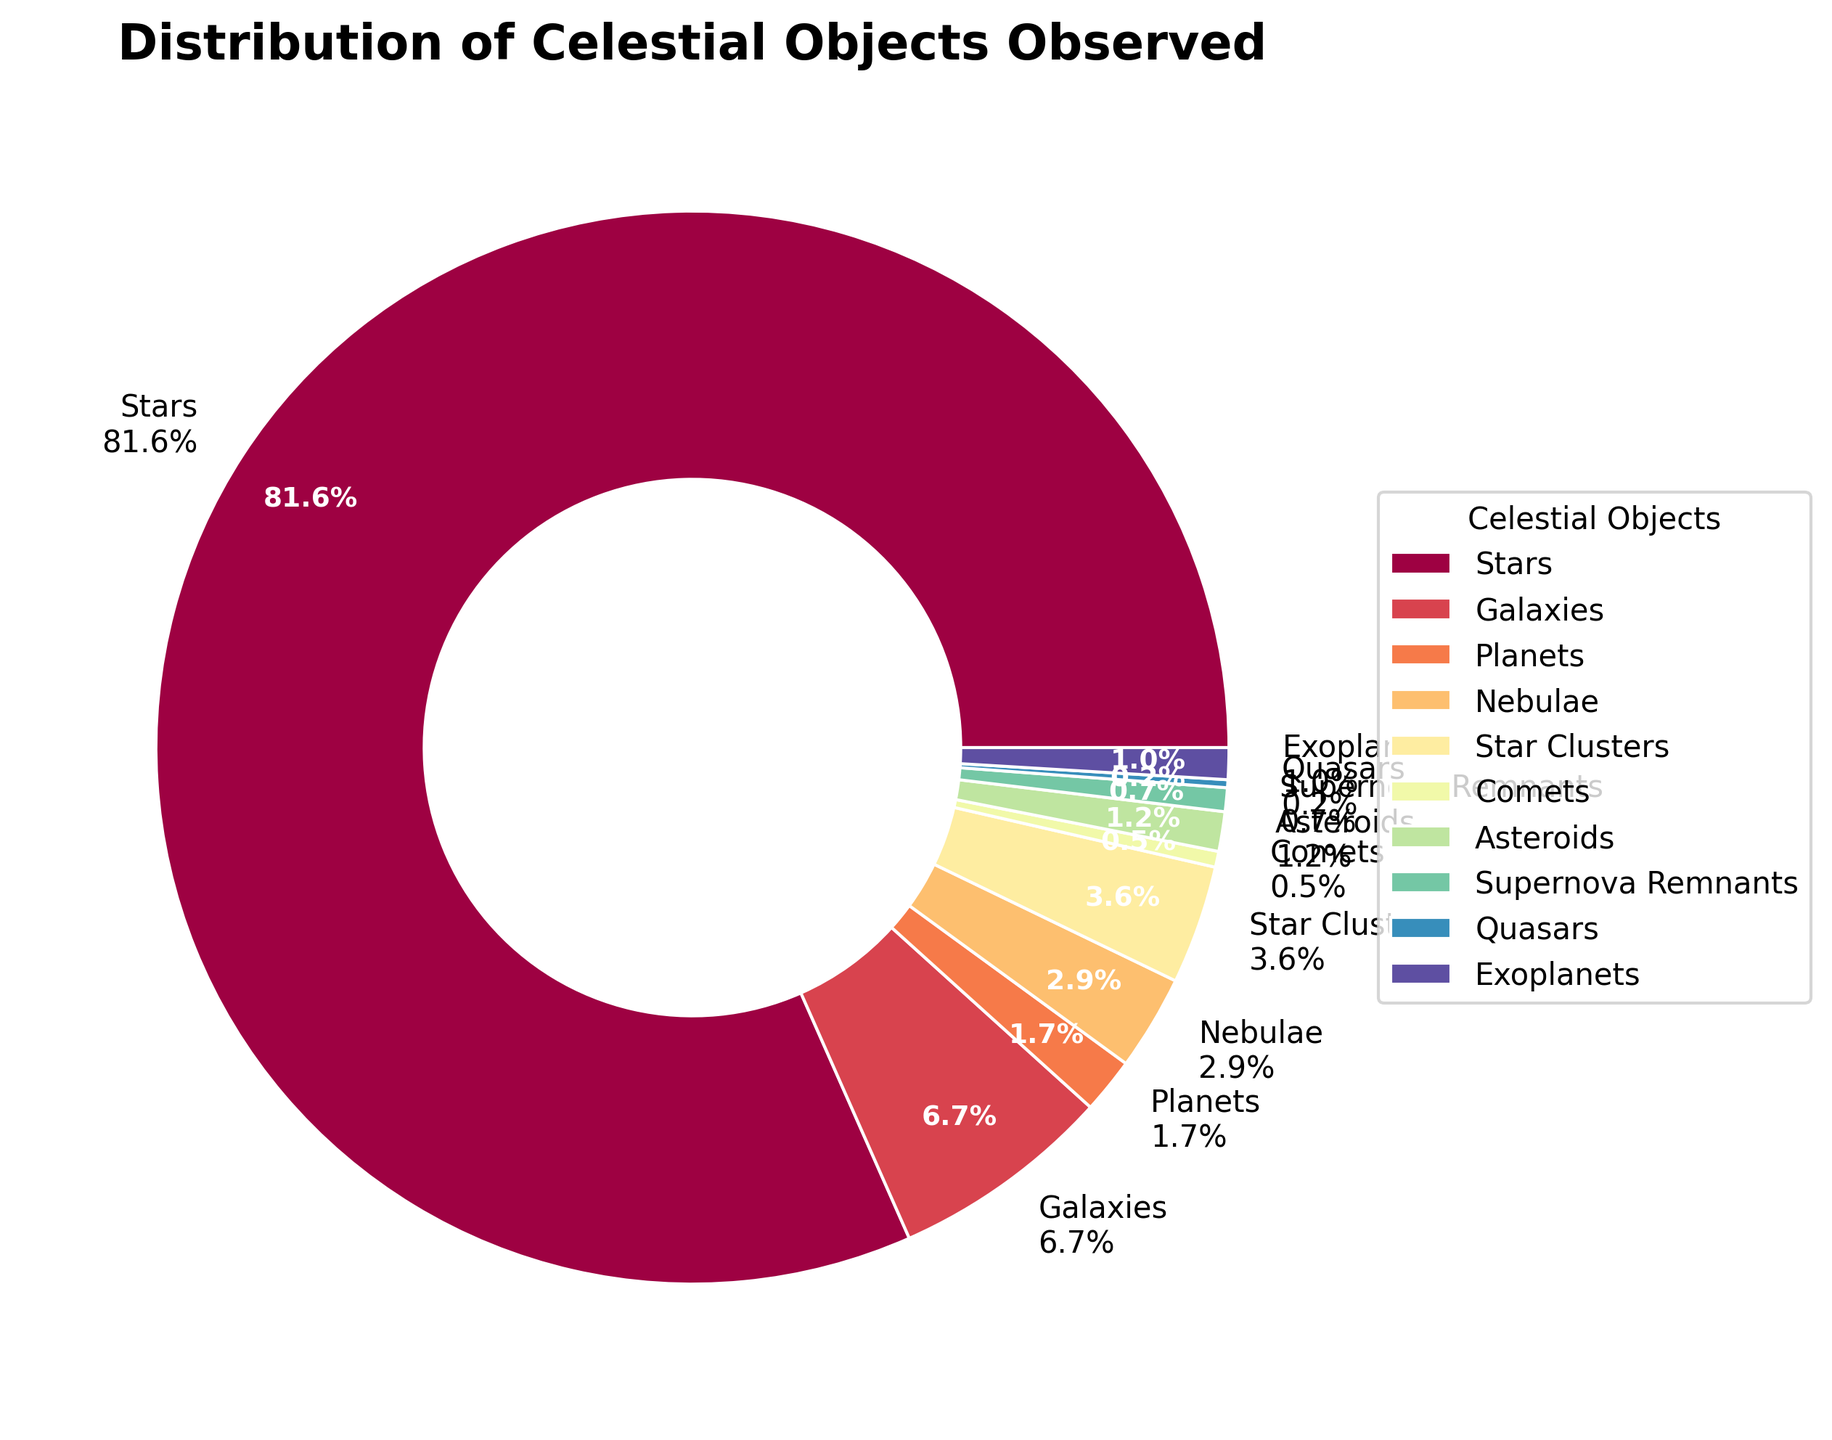Which type of celestial object has the highest count? By visually inspecting the pie chart, we identify the label with the largest segment. The segment for "Stars" is the largest, indicating that it has the highest count among the celestial objects.
Answer: Stars How many more stars were observed than galaxies? First, note the counts from the legend or segments: Stars (342) and Galaxies (28). The difference is calculated by subtracting the count of Galaxies from Stars: 342 - 28 = 314.
Answer: 314 What percentage of the total observations do planets make up? The pie chart shows the percentage directly as part of the label for each segment. The segment for "Planets" is labeled with "1.6%", indicating it represents 1.6% of the total observations.
Answer: 1.6% How many celestial objects were observed in total? Sum the counts for all celestial object types: 342 (Stars) + 28 (Galaxies) + 7 (Planets) + 12 (Nebulae) + 15 (Star Clusters) + 2 (Comets) + 5 (Asteroids) + 3 (Supernova Remnants) + 1 (Quasars) + 4 (Exoplanets) = 419.
Answer: 419 Which celestial object types together constitute less than 5% of the total observations? Identify the segments with percentages less than 5%: "Planets" (1.6%), "Nebulae" (2.9%), "Star Clusters" (3.6%), "Comets" (0.5%), "Asteroids" (1.2%), "Supernova Remnants" (0.7%), and "Quasars" (0.2%).
Answer: Planets, Nebulae, Star Clusters, Comets, Asteroids, Supernova Remnants, Quasars Which celestial object type has the smallest count? Visually find the smallest segment in the pie chart. The segment labeled "Quasars" has the smallest percentage (0.2%), indicating it has the smallest count.
Answer: Quasars What is the combined percentage of stars and galaxies? Read the percentages for Stars and Galaxies: Stars (81.6%) and Galaxies (6.7%). Add these percentages: 81.6% + 6.7% = 88.3%.
Answer: 88.3% By how much does the count of exoplanets differ from the count of comets? Note the counts from the chart: Exoplanets (4) and Comets (2). The difference is calculated by subtracting the smaller count from the larger count: 4 - 2 = 2.
Answer: 2 